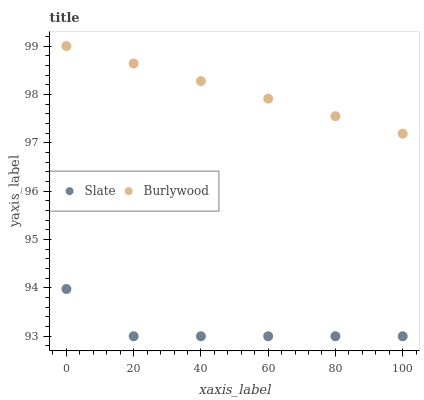Does Slate have the minimum area under the curve?
Answer yes or no. Yes. Does Burlywood have the maximum area under the curve?
Answer yes or no. Yes. Does Slate have the maximum area under the curve?
Answer yes or no. No. Is Burlywood the smoothest?
Answer yes or no. Yes. Is Slate the roughest?
Answer yes or no. Yes. Is Slate the smoothest?
Answer yes or no. No. Does Slate have the lowest value?
Answer yes or no. Yes. Does Burlywood have the highest value?
Answer yes or no. Yes. Does Slate have the highest value?
Answer yes or no. No. Is Slate less than Burlywood?
Answer yes or no. Yes. Is Burlywood greater than Slate?
Answer yes or no. Yes. Does Slate intersect Burlywood?
Answer yes or no. No. 